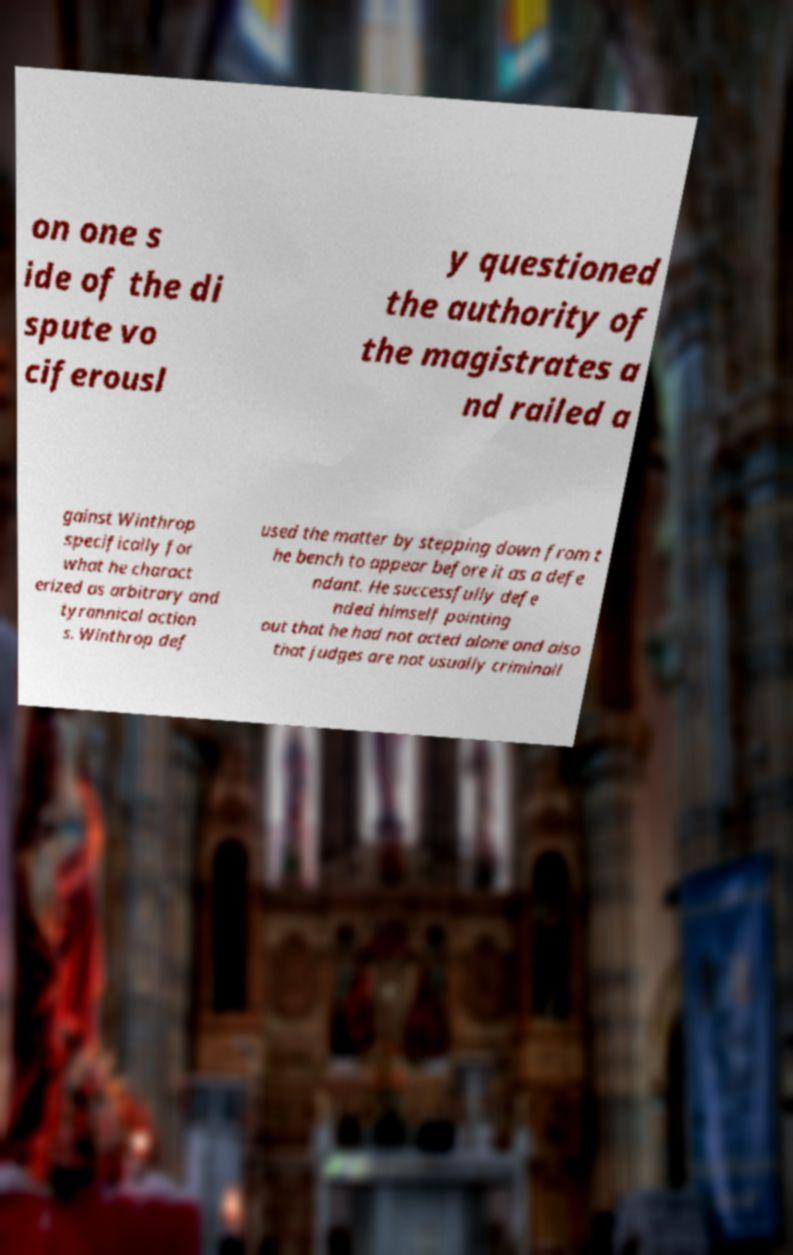I need the written content from this picture converted into text. Can you do that? on one s ide of the di spute vo ciferousl y questioned the authority of the magistrates a nd railed a gainst Winthrop specifically for what he charact erized as arbitrary and tyrannical action s. Winthrop def used the matter by stepping down from t he bench to appear before it as a defe ndant. He successfully defe nded himself pointing out that he had not acted alone and also that judges are not usually criminall 